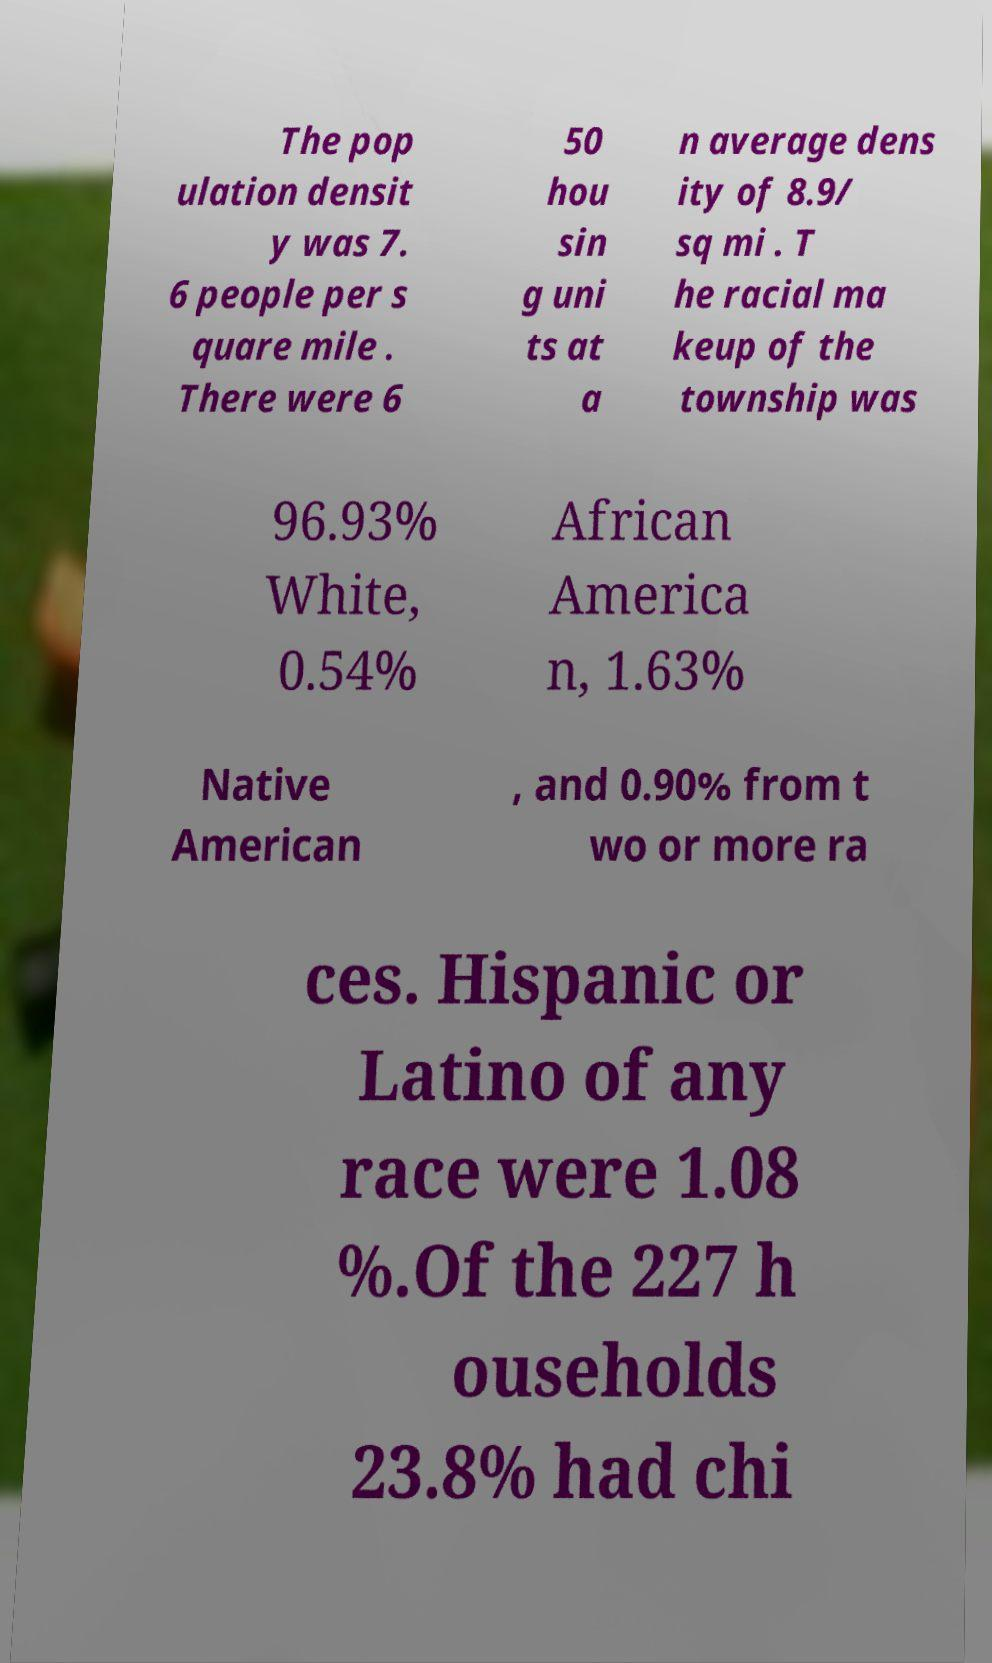Please identify and transcribe the text found in this image. The pop ulation densit y was 7. 6 people per s quare mile . There were 6 50 hou sin g uni ts at a n average dens ity of 8.9/ sq mi . T he racial ma keup of the township was 96.93% White, 0.54% African America n, 1.63% Native American , and 0.90% from t wo or more ra ces. Hispanic or Latino of any race were 1.08 %.Of the 227 h ouseholds 23.8% had chi 